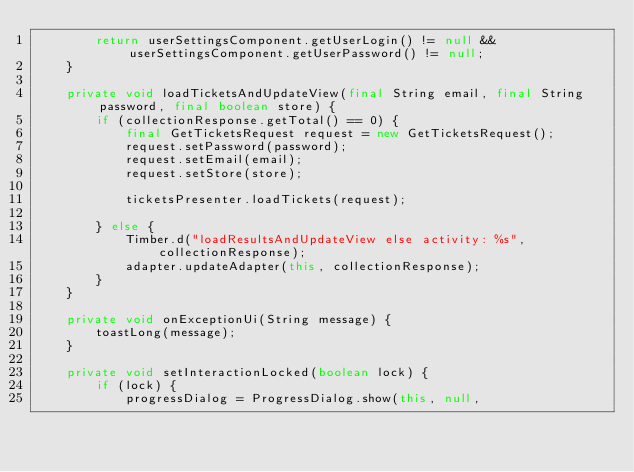<code> <loc_0><loc_0><loc_500><loc_500><_Java_>        return userSettingsComponent.getUserLogin() != null && userSettingsComponent.getUserPassword() != null;
    }

    private void loadTicketsAndUpdateView(final String email, final String password, final boolean store) {
        if (collectionResponse.getTotal() == 0) {
            final GetTicketsRequest request = new GetTicketsRequest();
            request.setPassword(password);
            request.setEmail(email);
            request.setStore(store);

            ticketsPresenter.loadTickets(request);

        } else {
            Timber.d("loadResultsAndUpdateView else activity: %s", collectionResponse);
            adapter.updateAdapter(this, collectionResponse);
        }
    }

    private void onExceptionUi(String message) {
        toastLong(message);
    }

    private void setInteractionLocked(boolean lock) {
        if (lock) {
            progressDialog = ProgressDialog.show(this, null,</code> 